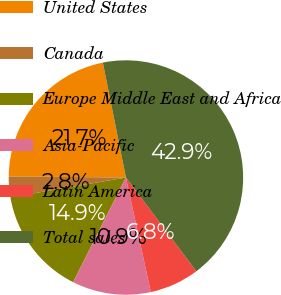<chart> <loc_0><loc_0><loc_500><loc_500><pie_chart><fcel>United States<fcel>Canada<fcel>Europe Middle East and Africa<fcel>Asia-Pacific<fcel>Latin America<fcel>Total sales<nl><fcel>21.7%<fcel>2.84%<fcel>14.86%<fcel>10.85%<fcel>6.84%<fcel>42.91%<nl></chart> 